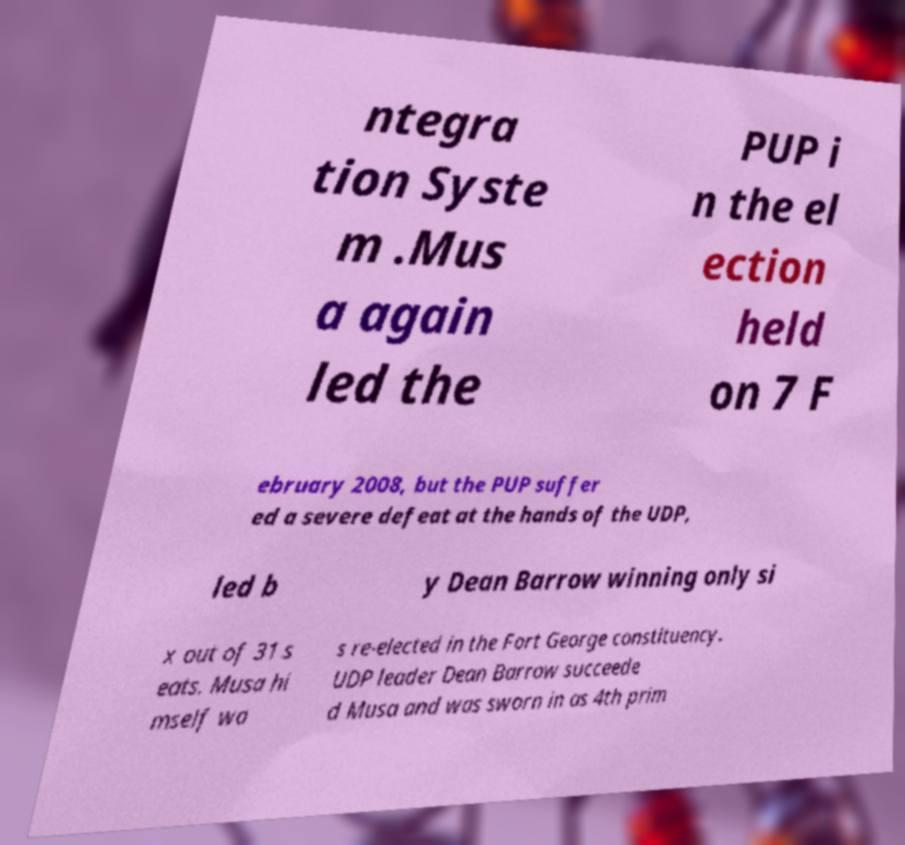Can you accurately transcribe the text from the provided image for me? ntegra tion Syste m .Mus a again led the PUP i n the el ection held on 7 F ebruary 2008, but the PUP suffer ed a severe defeat at the hands of the UDP, led b y Dean Barrow winning only si x out of 31 s eats. Musa hi mself wa s re-elected in the Fort George constituency. UDP leader Dean Barrow succeede d Musa and was sworn in as 4th prim 